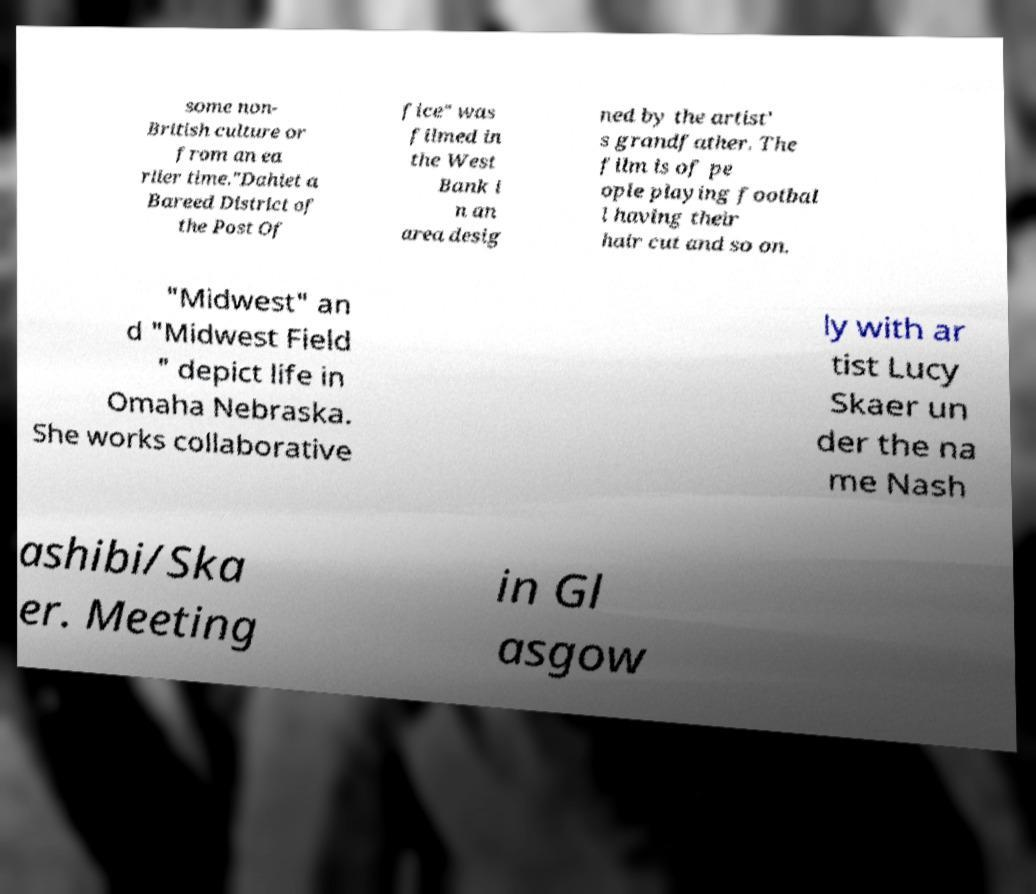What messages or text are displayed in this image? I need them in a readable, typed format. some non- British culture or from an ea rlier time."Dahiet a Bareed District of the Post Of fice" was filmed in the West Bank i n an area desig ned by the artist' s grandfather. The film is of pe ople playing footbal l having their hair cut and so on. "Midwest" an d "Midwest Field " depict life in Omaha Nebraska. She works collaborative ly with ar tist Lucy Skaer un der the na me Nash ashibi/Ska er. Meeting in Gl asgow 